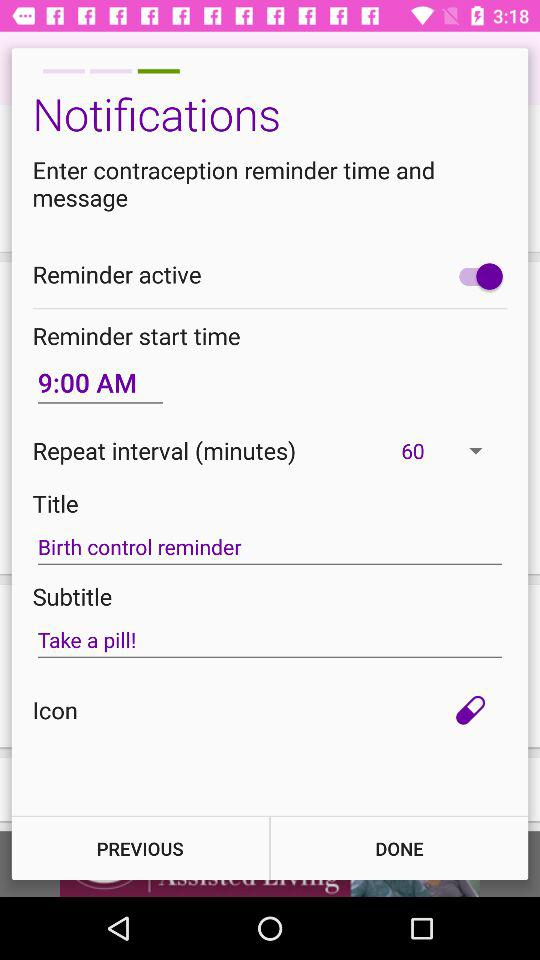What is the subtitle of the reminder?
Answer the question using a single word or phrase. Take a pill! 